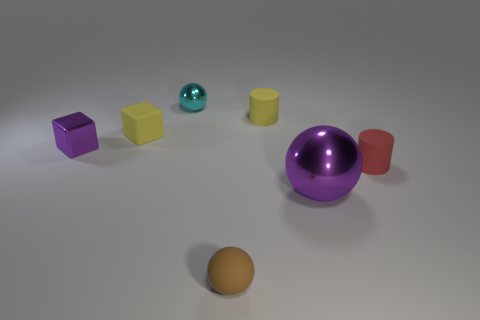Are there any large purple metallic blocks?
Your response must be concise. No. How many other things are there of the same material as the tiny purple block?
Provide a succinct answer. 2. What is the material of the yellow cube that is the same size as the red thing?
Make the answer very short. Rubber. Does the metallic thing behind the yellow rubber cylinder have the same shape as the tiny purple thing?
Your answer should be very brief. No. Does the large thing have the same color as the tiny metallic sphere?
Provide a succinct answer. No. How many objects are small brown things in front of the purple cube or small purple metallic cubes?
Keep it short and to the point. 2. What shape is the purple object that is the same size as the yellow block?
Your response must be concise. Cube. Do the matte cube that is behind the tiny rubber sphere and the purple metallic thing in front of the metallic block have the same size?
Provide a short and direct response. No. There is a big ball that is the same material as the purple block; what is its color?
Offer a terse response. Purple. Does the small sphere behind the shiny block have the same material as the tiny thing in front of the big purple object?
Your answer should be compact. No. 